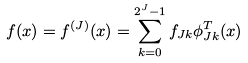Convert formula to latex. <formula><loc_0><loc_0><loc_500><loc_500>f ( x ) = f ^ { ( J ) } ( x ) = \sum _ { k = 0 } ^ { 2 ^ { J } - 1 } f _ { J k } \phi _ { J k } ^ { T } ( x )</formula> 